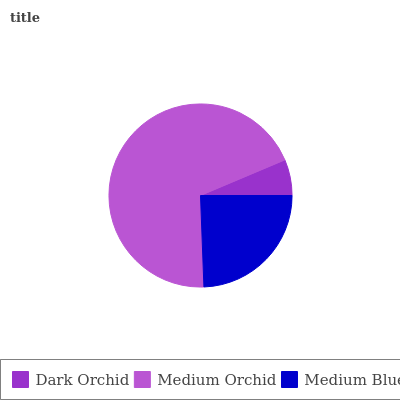Is Dark Orchid the minimum?
Answer yes or no. Yes. Is Medium Orchid the maximum?
Answer yes or no. Yes. Is Medium Blue the minimum?
Answer yes or no. No. Is Medium Blue the maximum?
Answer yes or no. No. Is Medium Orchid greater than Medium Blue?
Answer yes or no. Yes. Is Medium Blue less than Medium Orchid?
Answer yes or no. Yes. Is Medium Blue greater than Medium Orchid?
Answer yes or no. No. Is Medium Orchid less than Medium Blue?
Answer yes or no. No. Is Medium Blue the high median?
Answer yes or no. Yes. Is Medium Blue the low median?
Answer yes or no. Yes. Is Dark Orchid the high median?
Answer yes or no. No. Is Dark Orchid the low median?
Answer yes or no. No. 